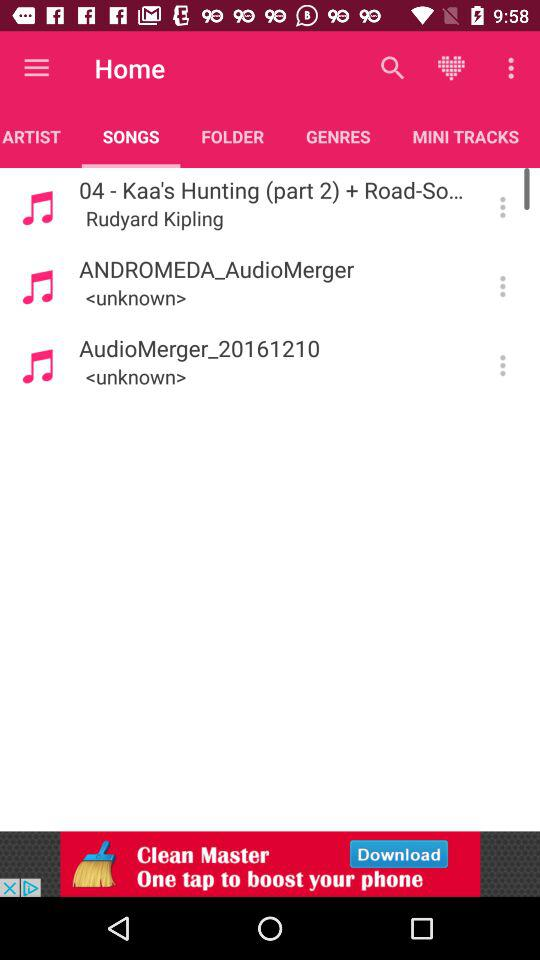Can you write the few names of songs given on the screen? The few names of songs are "04 - Kaa's Hunting (part 2) + Road-So...", "ANDROMEDA_AudioMerger" and "AudioMerger_20161210". 